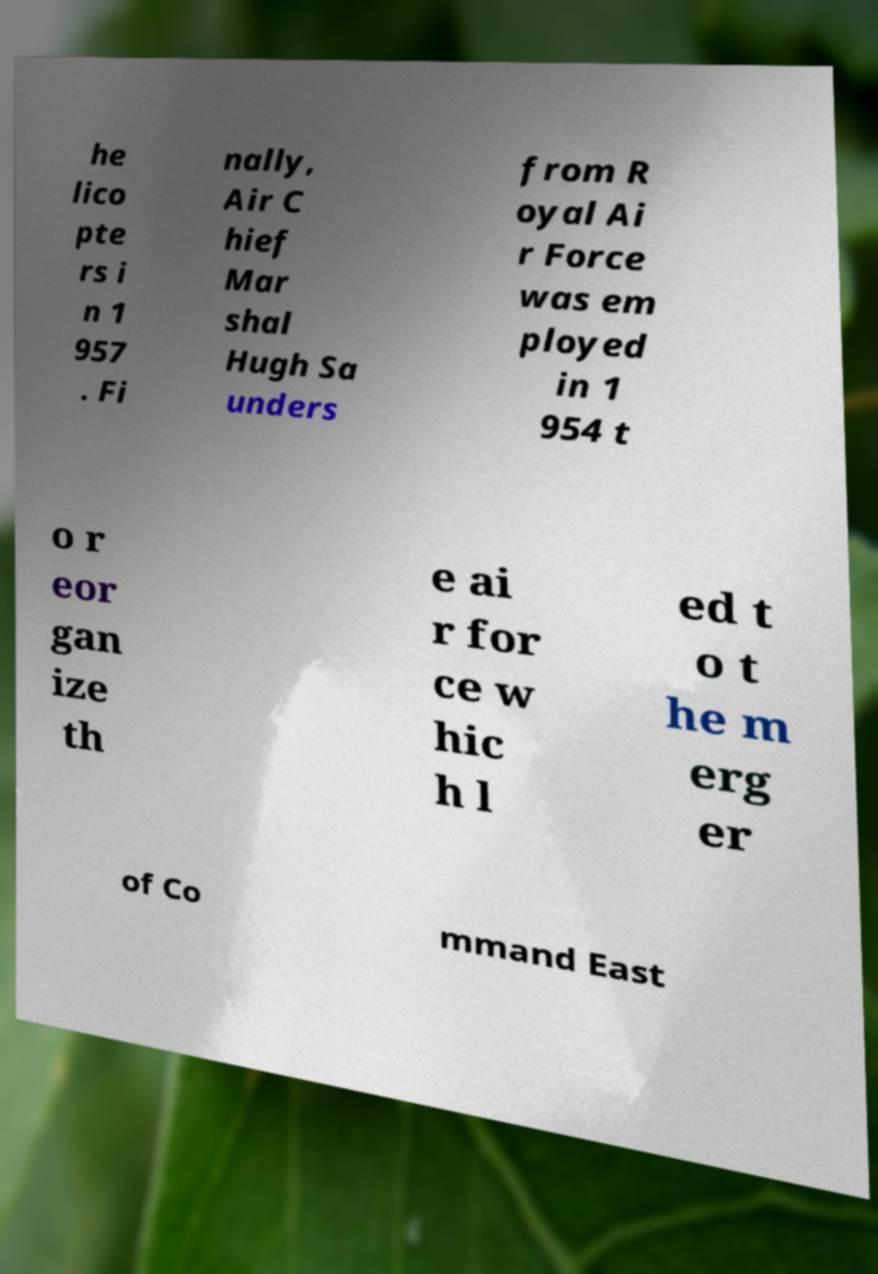Please read and relay the text visible in this image. What does it say? he lico pte rs i n 1 957 . Fi nally, Air C hief Mar shal Hugh Sa unders from R oyal Ai r Force was em ployed in 1 954 t o r eor gan ize th e ai r for ce w hic h l ed t o t he m erg er of Co mmand East 